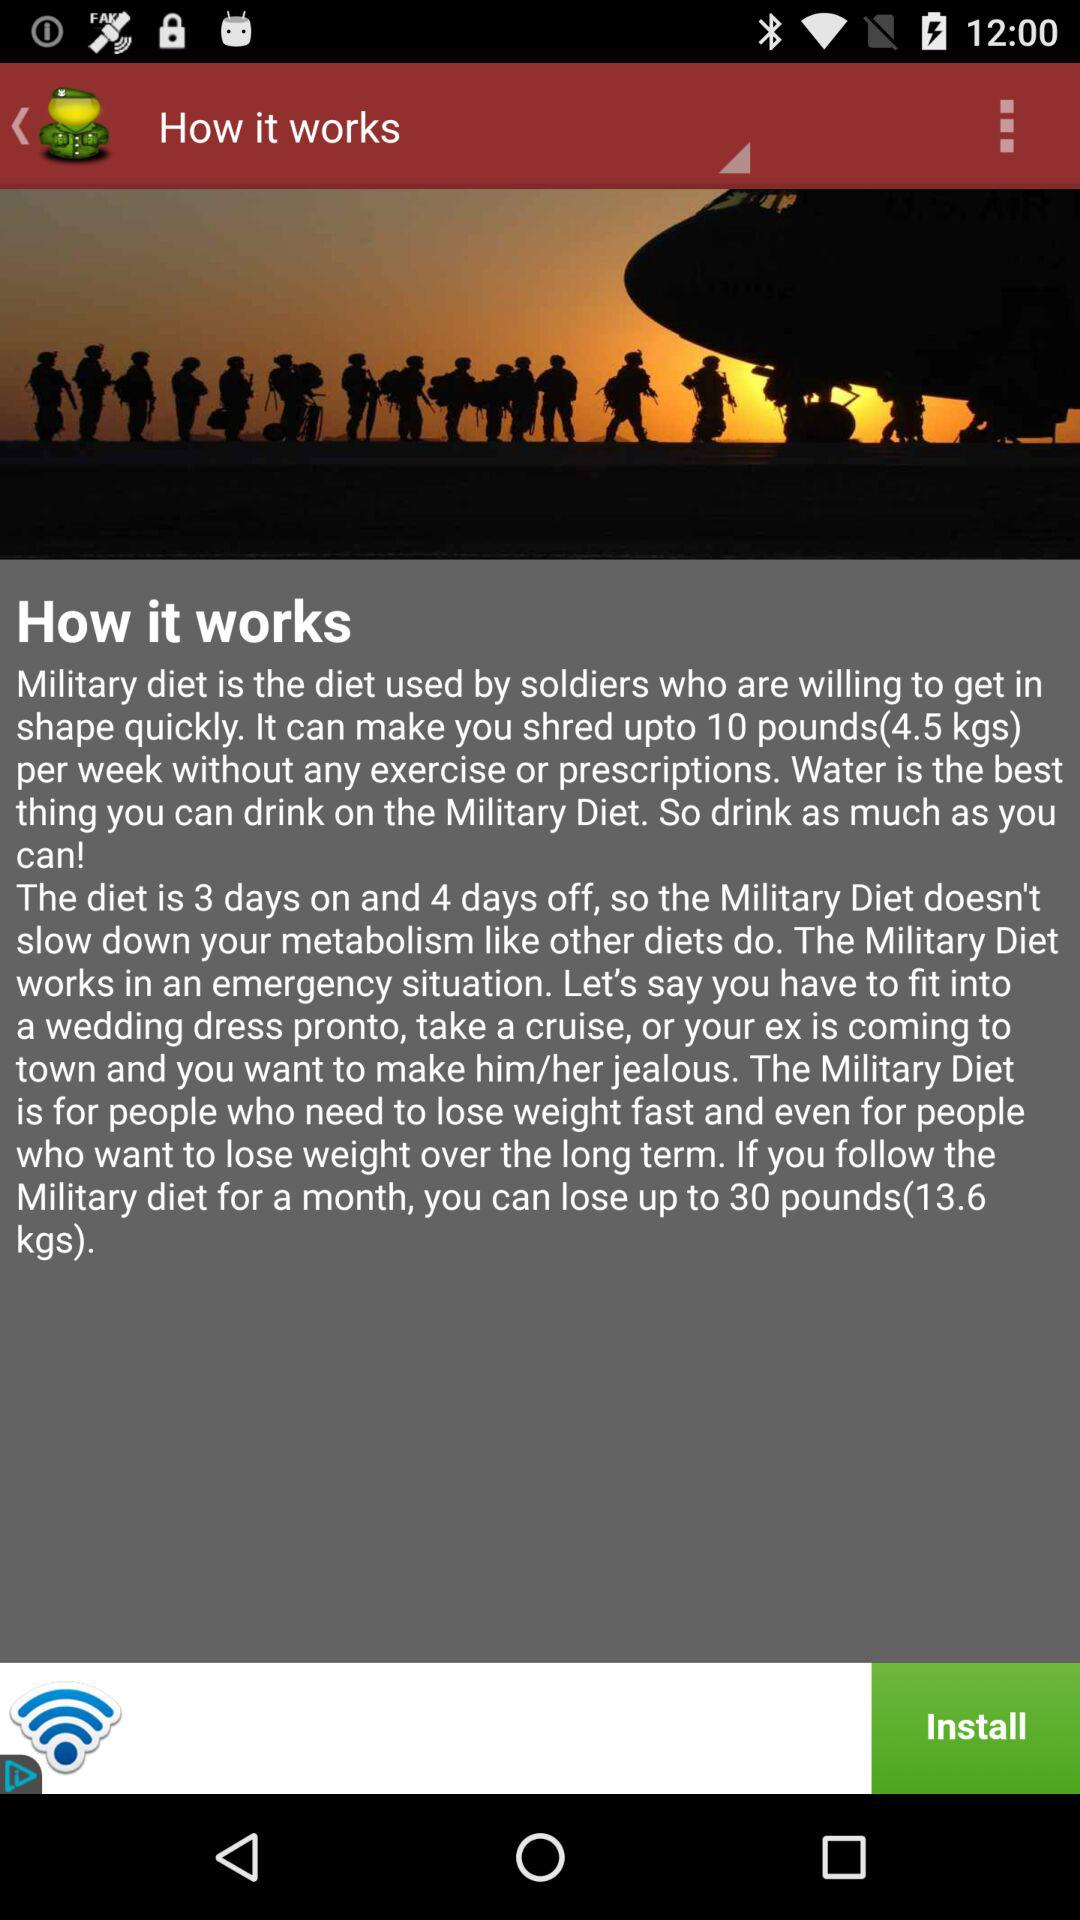How many days off does the military diet have?
Answer the question using a single word or phrase. 4 